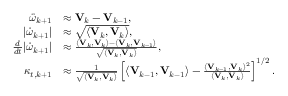Convert formula to latex. <formula><loc_0><loc_0><loc_500><loc_500>\begin{array} { r l } { \ddot { \omega } _ { k + 1 } } & { \approx V _ { k } - V _ { k - 1 } , } \\ { | \dot { \omega } _ { k + 1 } | } & { \approx \sqrt { \langle V _ { k } , V _ { k } \rangle } , } \\ { \frac { d } { d t } | \dot { \omega } _ { k + 1 } | } & { \approx \frac { \langle V _ { k } , V _ { k } \rangle - \langle V _ { k } , V _ { k - 1 } \rangle } { \sqrt { \langle V _ { k } , V _ { k } \rangle } } , } \\ { \kappa _ { t , k + 1 } } & { \approx \frac { 1 } { \sqrt { \langle V _ { k } , V _ { k } \rangle } } \left [ \langle V _ { k - 1 } , V _ { k - 1 } \rangle - \frac { \langle V _ { k - 1 } , V _ { k } \rangle ^ { 2 } } { \langle V _ { k } , V _ { k } \rangle } \right ] ^ { 1 / 2 } . } \end{array}</formula> 